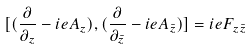Convert formula to latex. <formula><loc_0><loc_0><loc_500><loc_500>[ ( \frac { \partial } { \partial _ { z } } - i e A _ { z } ) , ( \frac { \partial } { \partial _ { \bar { z } } } - i e A _ { \bar { z } } ) ] = i e F _ { z \bar { z } }</formula> 